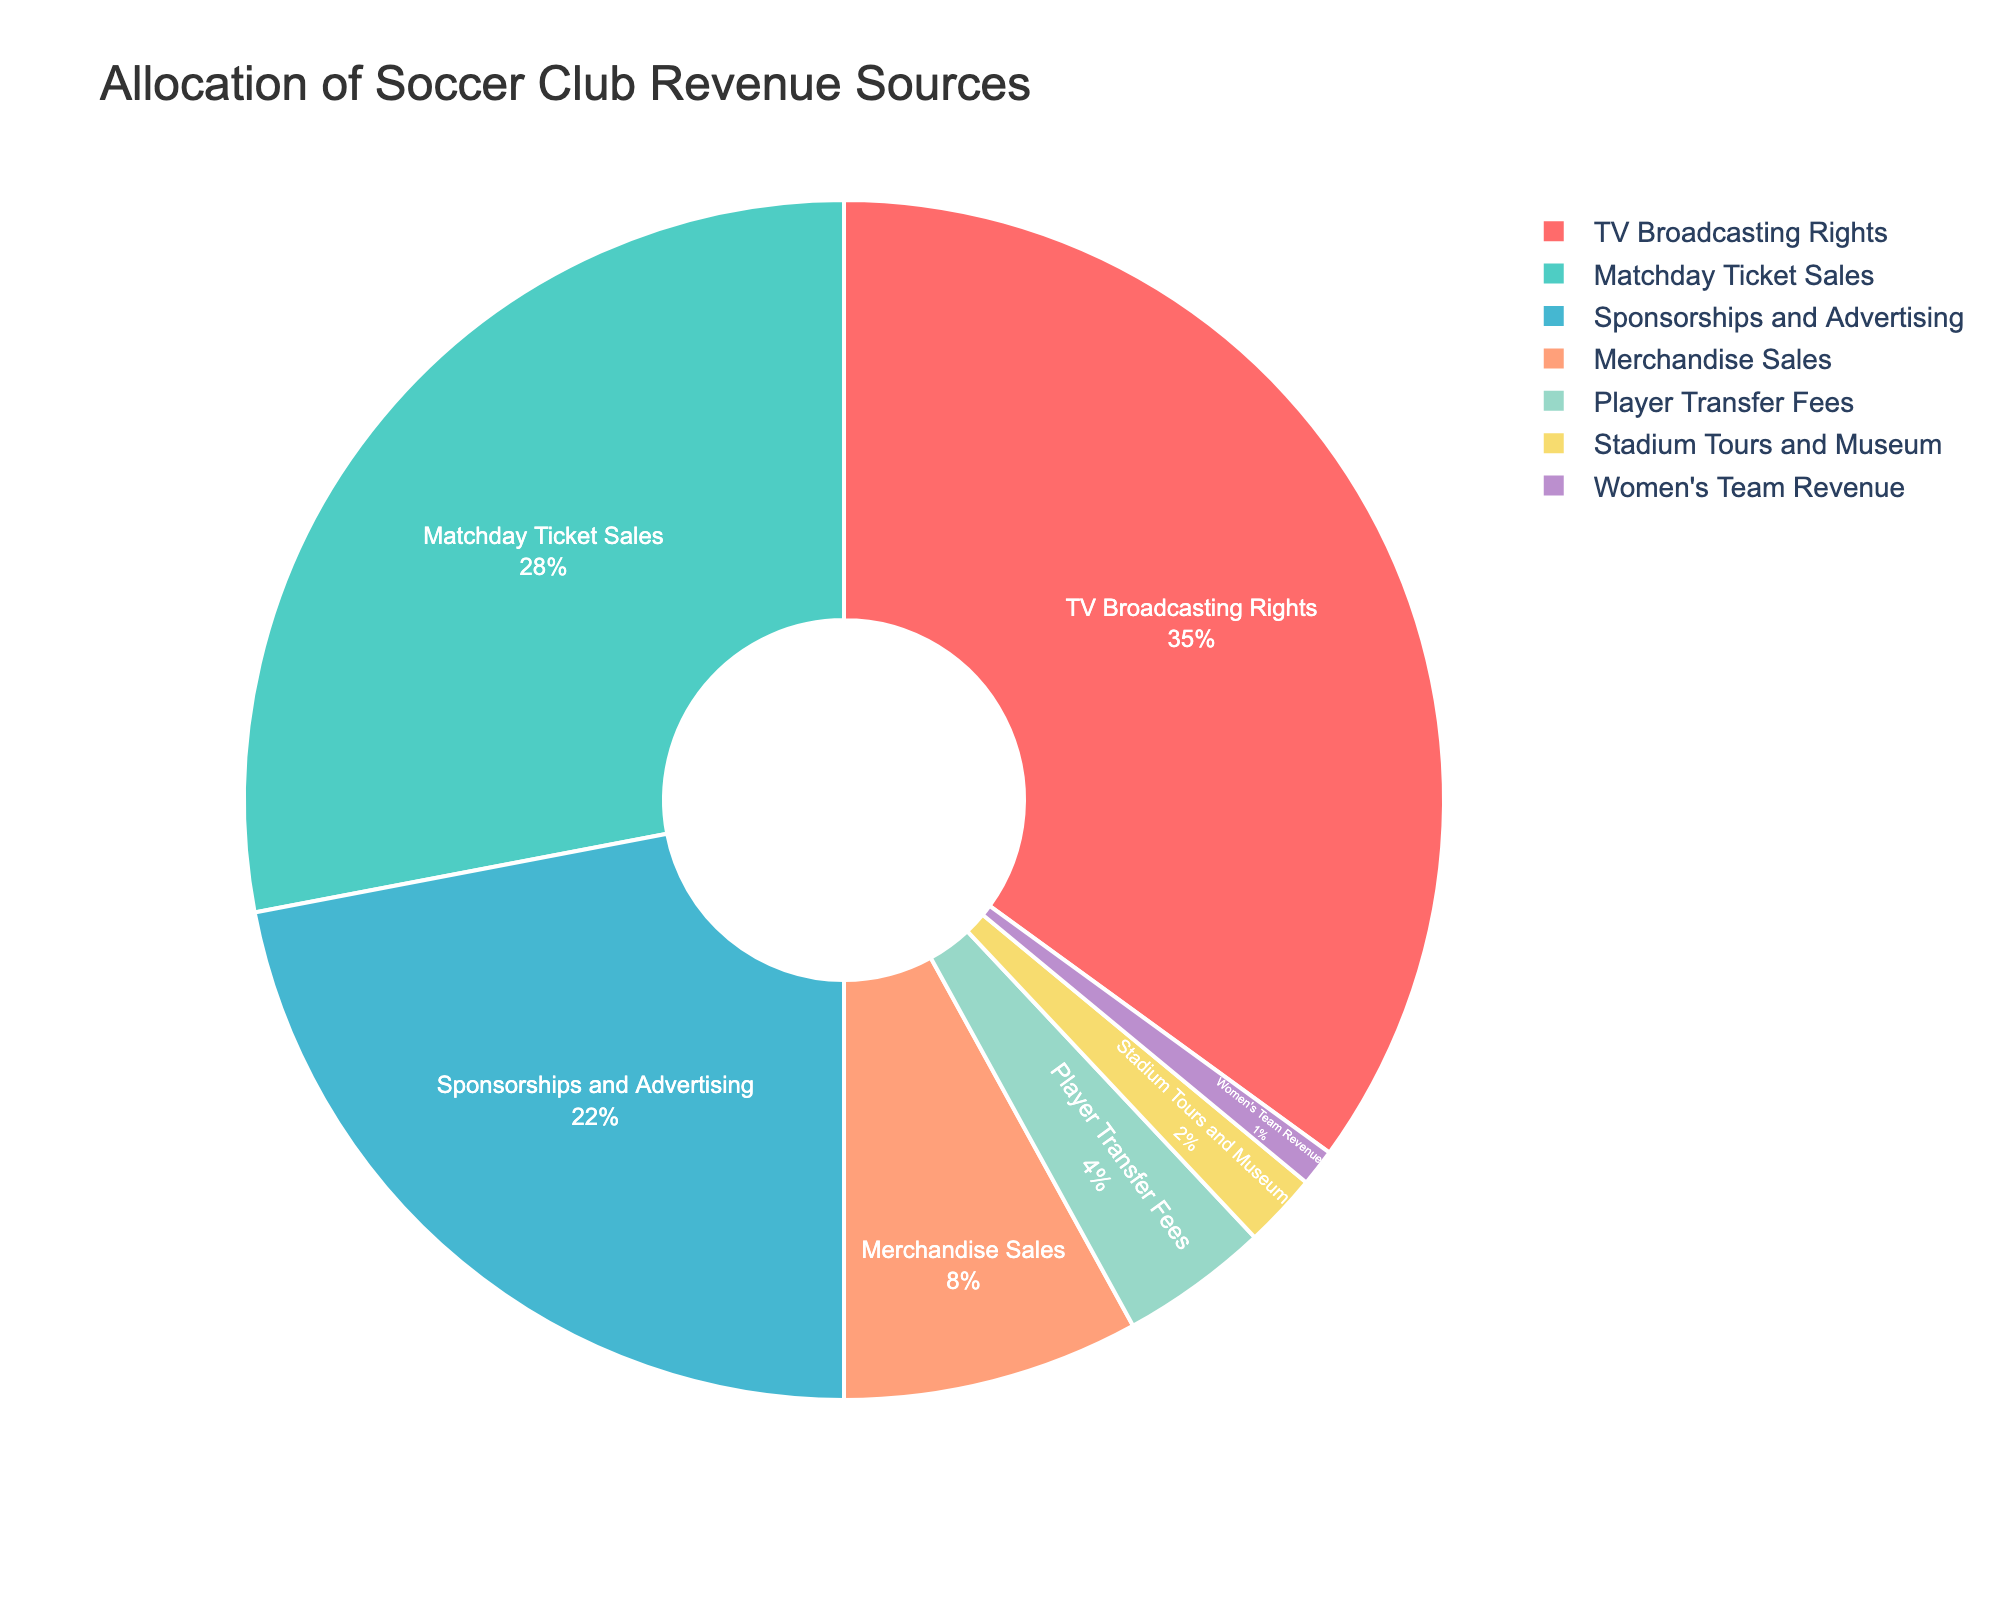what's the largest source of revenue? The pie chart shows different revenue sources. By looking at the segments, the largest segment corresponds to TV Broadcasting Rights, which is highlighted by its dominant size and percentage.
Answer: TV Broadcasting Rights Which revenue source contributes the least? Observing the pie chart, the smallest segment represents Women's Team Revenue. Its percentage and the segment's size indicate it contributes the least to the total revenue.
Answer: Women's Team Revenue What's the combined percentage of revenue from Matchday Ticket Sales and Merchandise Sales? Add the percentages for Matchday Ticket Sales and Merchandise Sales from the chart: 28% + 8% = 36%.
Answer: 36% How much more does TV Broadcasting Rights bring in compared to Player Transfer Fees? Subtract the percentage of Player Transfer Fees from TV Broadcasting Rights: 35% - 4% = 31%.
Answer: 31% Which sources combined contribute more to the revenue: Sponsorships and Advertising with Player Transfer Fees or Matchday Ticket Sales with Stadium Tours and Museum? Calculate separately: Sponsorships and Advertising + Player Transfer Fees = 22% + 4% = 26% and Matchday Ticket Sales + Stadium Tours and Museum = 28% + 2% = 30%.
Answer: Matchday Ticket Sales with Stadium Tours and Museum Which colored segment represents Merchandise Sales? Find the color corresponding to Merchandise Sales in the pie chart; it's shown as a soft orange segment.
Answer: Soft orange Is the revenue from the Women's Team greater than 2%? The chart segment for Women's Team Revenue is 1%, which is less than 2%.
Answer: No What's the percentage difference between Sponsorships and Advertising and Matchday Ticket Sales? Subtract Matchday Ticket Sales from Sponsorships and Advertising: 28% - 22% = 6%.
Answer: 6% If the revenue from TV Broadcasting Rights increased by 5%, what would its new percentage be? Add the increase to the current TV Broadcasting Rights percentage: 35% + 5% = 40%.
Answer: 40% Are Merchandise Sales and Player Transfer Fees more than half of TV Broadcasting Rights' revenue? Calculate the combined percentage of Merchandise Sales and Player Transfer Fees: 8% + 4% = 12%. Check if this is more than half of TV Broadcasting Rights' 35%: 35% ÷ 2 = 17.5%. Since 12% < 17.5%, they are not more.
Answer: No 